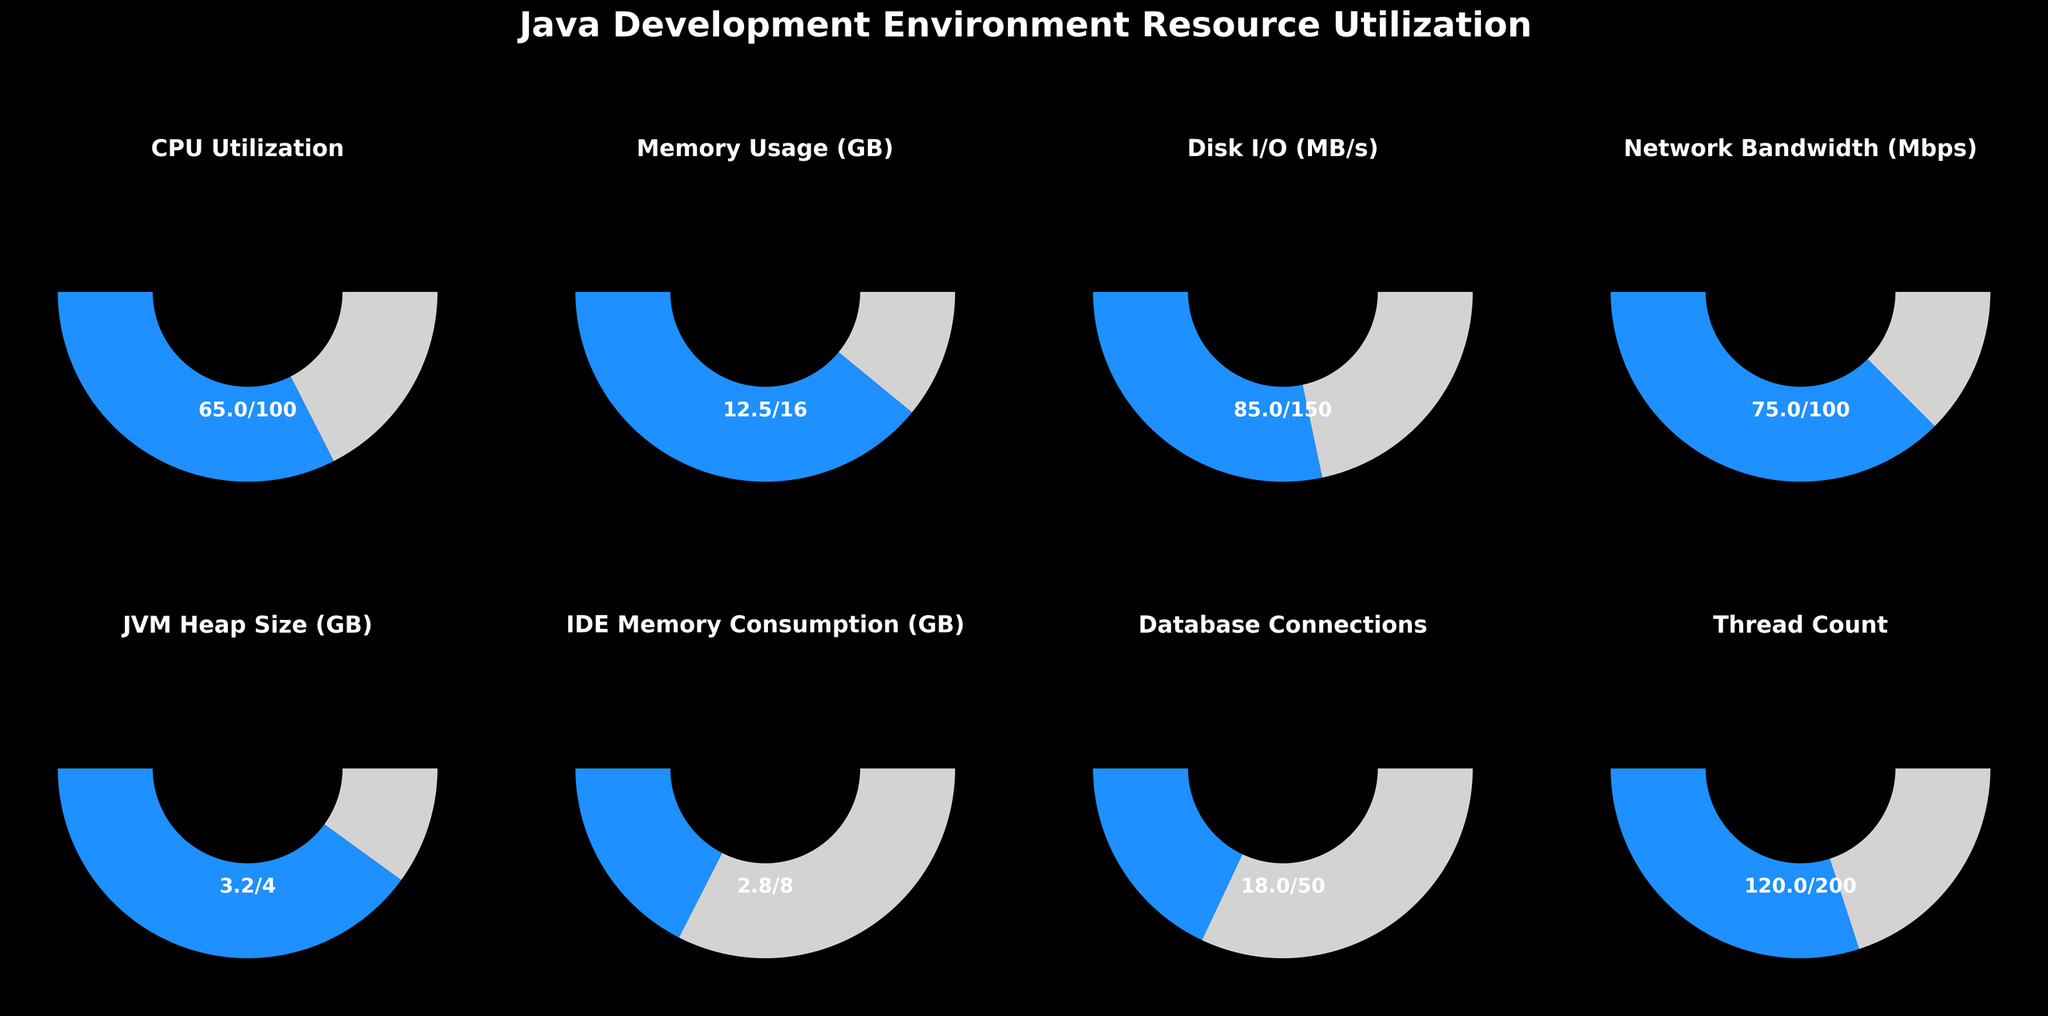what is the title of the figure? The title of the figure is located at the top center and is styled in a bold and large font for prominence. It reads "Java Development Environment Resource Utilization".
Answer: Java Development Environment Resource Utilization How much memory is being used by the IDE? The gauge chart labeled "IDE Memory Consumption (GB)" shows the memory usage. The text below the meter displays "2.8/8", indicating the IDE uses 2.8 GB of memory.
Answer: 2.8 GB What is the maximum disk I/O capacity available? The gauge chart titled "Disk I/O (MB/s)" includes information on both current usage and maximum capacity. The maximum disk I/O capacity is indicated by the denominator in the ratio displayed, which is 150 MB/s.
Answer: 150 MB/s Which resource has the highest percentage utilization? To determine this, calculate the percentage utilization for each resource by dividing the usage by the maximum and then comparing all percentage results. For "CPU Utilization," the percentage is 65%. For "Memory Usage," it is 78.1%. For "Disk I/O," it is 56.7%. For "Network Bandwidth," it is 75%. For "JVM Heap Size," it is 80%. For "IDE Memory Consumption," it is 35%. For "Database Connections," it is 36%. For "Thread Count," it is 60%. JVM Heap Size has the highest percentage utilization at 80%.
Answer: JVM Heap Size Is the CPU utilization higher or lower than the disk I/O usage? The CPU Utilization is shown to be 65 out of 100 and the Disk I/O usage is 85 out of 150. To compare, the CPU Utilization percentage is 65%, and the Disk I/O percentage is approximately 56.7%. Therefore, CPU utilization is higher than disk I/O usage.
Answer: Higher What is the mean of the Memory usage (GB) and IDE Memory Consumption (GB)? To calculate the mean of the Memory Usage and IDE Memory Consumption, sum the two values (12.5 GB + 2.8 GB) and divide by 2. The sum is 15.3 GB, and the mean is 15.3 GB / 2 = 7.65 GB.
Answer: 7.65 GB What is the difference between the current usage of Network Bandwidth and Database Connections? The chart for Network Bandwidth shows a current usage of 75 Mbps while for Database Connections it is 18. The difference is 75 - 18 = 57.
Answer: 57 Mbps Which resource has the lowest percentage utilization? The percentage utilization for each resource is calculated: CPU Utilization is 65%, Memory Usage is 78.1%, Disk I/O is 56.7%, Network Bandwidth is 75%, JVM Heap Size is 80%, IDE Memory Consumption is 35%, Database Connections is 36%, and Thread Count is 60%. The lowest utilization percentage is for IDE Memory Consumption at 35%.
Answer: IDE Memory Consumption What is the sum of the usage values for CPU, Memory Usage, and Network Bandwidth? Summing the usage values for CPU (65), Memory Usage (12.5), and Network Bandwidth (75) gives 65 + 12.5 + 75 = 152.5.
Answer: 152.5 What percentage of the maximum is the JVM Heap Size currently at? To calculate the percentage, divide the current usage of the JVM Heap Size (3.2 GB) by the maximum (4 GB) and then multiply by 100: (3.2 / 4) * 100 = 80%.
Answer: 80% 